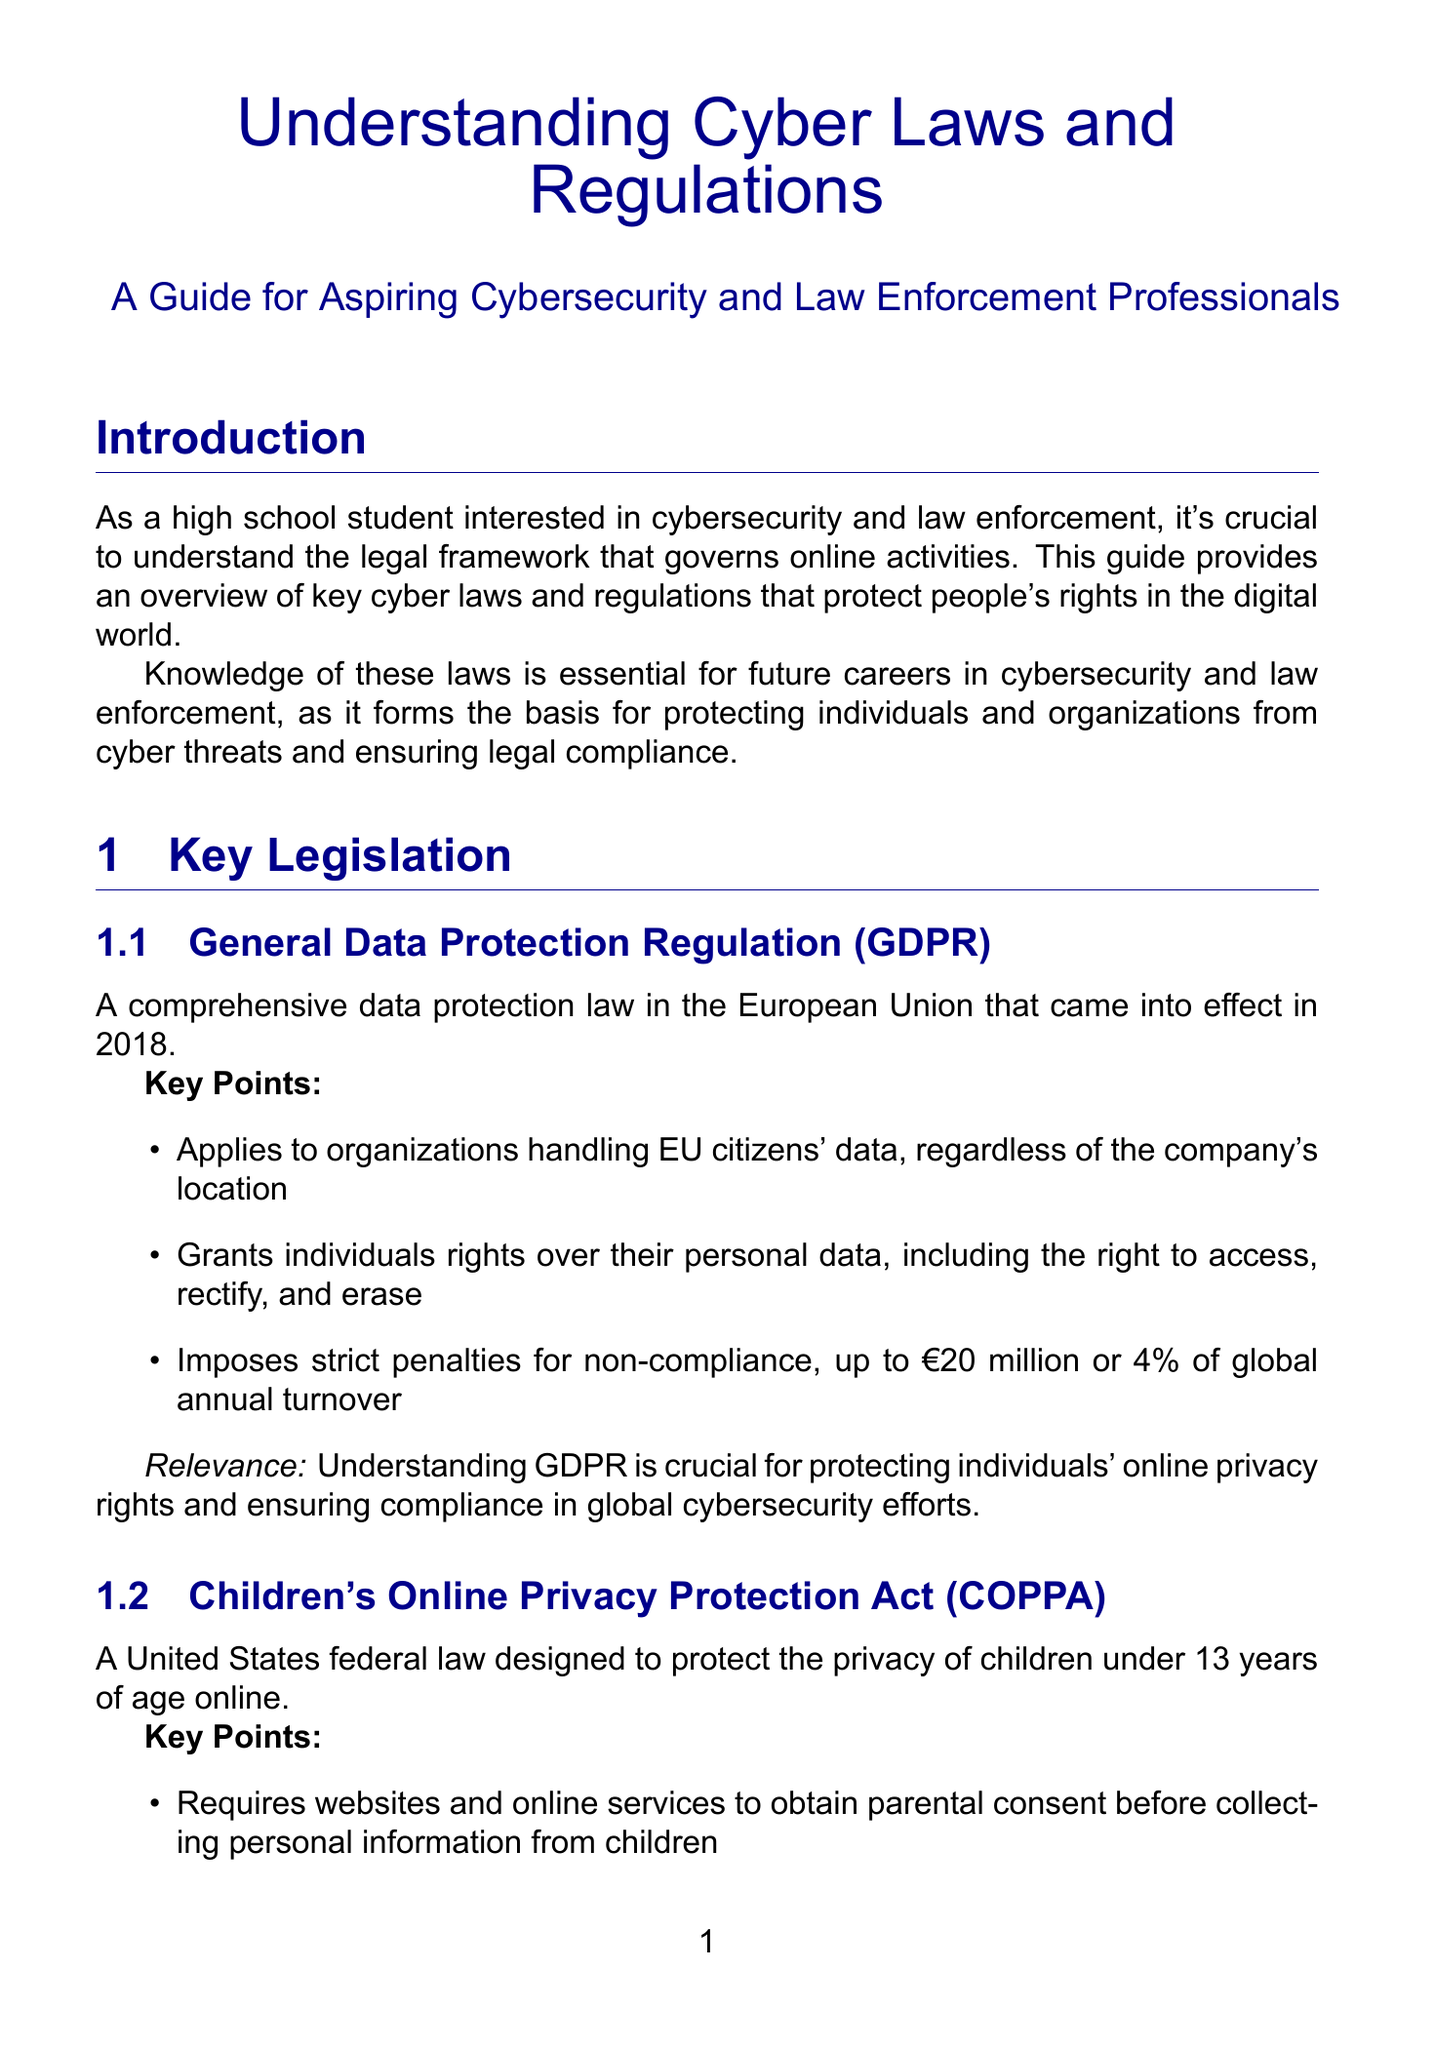What is GDPR? GDPR is a comprehensive data protection law in the European Union that came into effect in 2018.
Answer: A comprehensive data protection law in the European Union that came into effect in 2018 What is the maximum penalty for non-compliance with GDPR? The document specifies that GDPR imposes strict penalties for non-compliance.
Answer: €20 million or 4% of global annual turnover What age group does COPPA protect? COPPA is designed to protect the privacy of children under a specific age.
Answer: Under 13 years of age Which agency enforces COPPA? The document names the agency responsible for enforcing COPPA.
Answer: Federal Trade Commission (FTC) What year was the CFAA enacted? The document states the year when the CFAA was enacted, addressing computer-related offenses.
Answer: 1986 What is one example of international cyber law mentioned? The document provides examples of international cyber laws, indicating how they vary across countries.
Answer: China's Cybersecurity Law Which US agency investigates financially-motivated cybercrime? The document lists various agencies and their roles in cybercrime investigations.
Answer: U.S. Secret Service Electronic Crimes Task Forces What is an emerging area in cyber laws and regulations? The document discusses future trends, including emerging areas related to technology.
Answer: Artificial Intelligence and machine learning regulations 